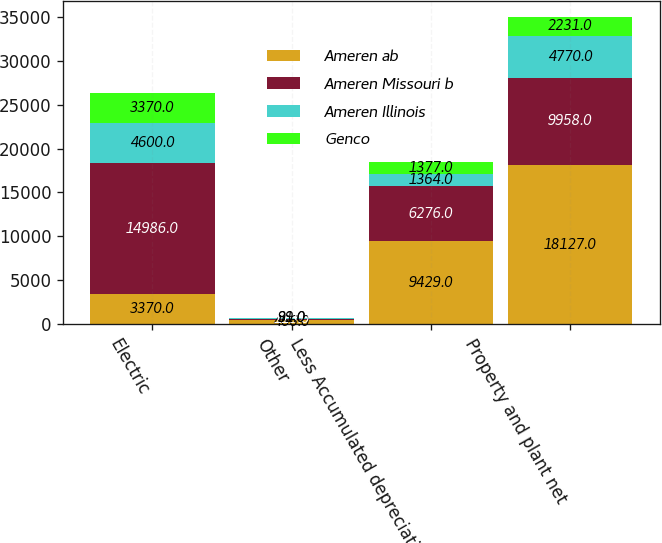Convert chart. <chart><loc_0><loc_0><loc_500><loc_500><stacked_bar_chart><ecel><fcel>Electric<fcel>Other<fcel>Less Accumulated depreciation<fcel>Property and plant net<nl><fcel>Ameren ab<fcel>3370<fcel>466<fcel>9429<fcel>18127<nl><fcel>Ameren Missouri b<fcel>14986<fcel>113<fcel>6276<fcel>9958<nl><fcel>Ameren Illinois<fcel>4600<fcel>91<fcel>1364<fcel>4770<nl><fcel>Genco<fcel>3370<fcel>39<fcel>1377<fcel>2231<nl></chart> 